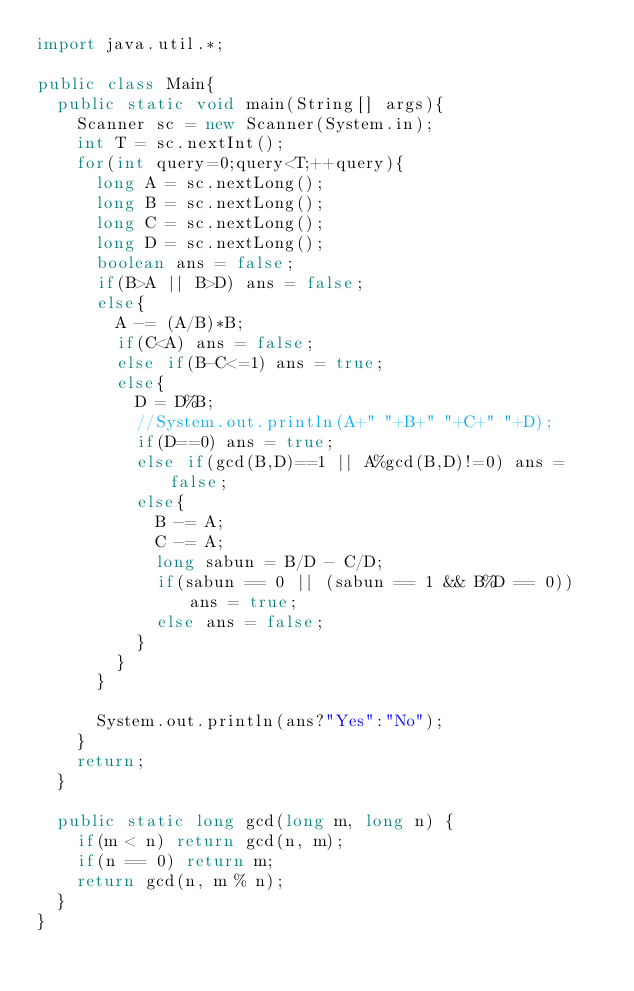Convert code to text. <code><loc_0><loc_0><loc_500><loc_500><_Java_>import java.util.*;
 
public class Main{
	public static void main(String[] args){
		Scanner sc = new Scanner(System.in);
		int T = sc.nextInt();
		for(int query=0;query<T;++query){
			long A = sc.nextLong();
			long B = sc.nextLong();
			long C = sc.nextLong();
			long D = sc.nextLong();
			boolean ans = false;
			if(B>A || B>D) ans = false;
			else{
				A -= (A/B)*B;
				if(C<A) ans = false;
				else if(B-C<=1) ans = true;
				else{
					D = D%B;
					//System.out.println(A+" "+B+" "+C+" "+D);
					if(D==0) ans = true;
					else if(gcd(B,D)==1 || A%gcd(B,D)!=0) ans = false;
					else{
						B -= A;
						C -= A;
						long sabun = B/D - C/D;
						if(sabun == 0 || (sabun == 1 && B%D == 0)) ans = true;
						else ans = false;
					}
				}
			}

			System.out.println(ans?"Yes":"No");
		}
		return;
	}

	public static long gcd(long m, long n) {
		if(m < n) return gcd(n, m);
		if(n == 0) return m;
		return gcd(n, m % n);
	}
}</code> 